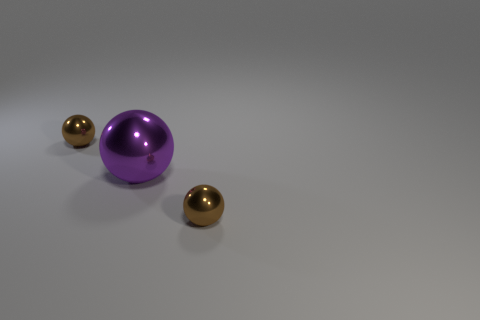Add 2 metallic things. How many objects exist? 5 Subtract 0 red cylinders. How many objects are left? 3 Subtract all tiny spheres. Subtract all purple metallic spheres. How many objects are left? 0 Add 1 big spheres. How many big spheres are left? 2 Add 1 purple metal balls. How many purple metal balls exist? 2 